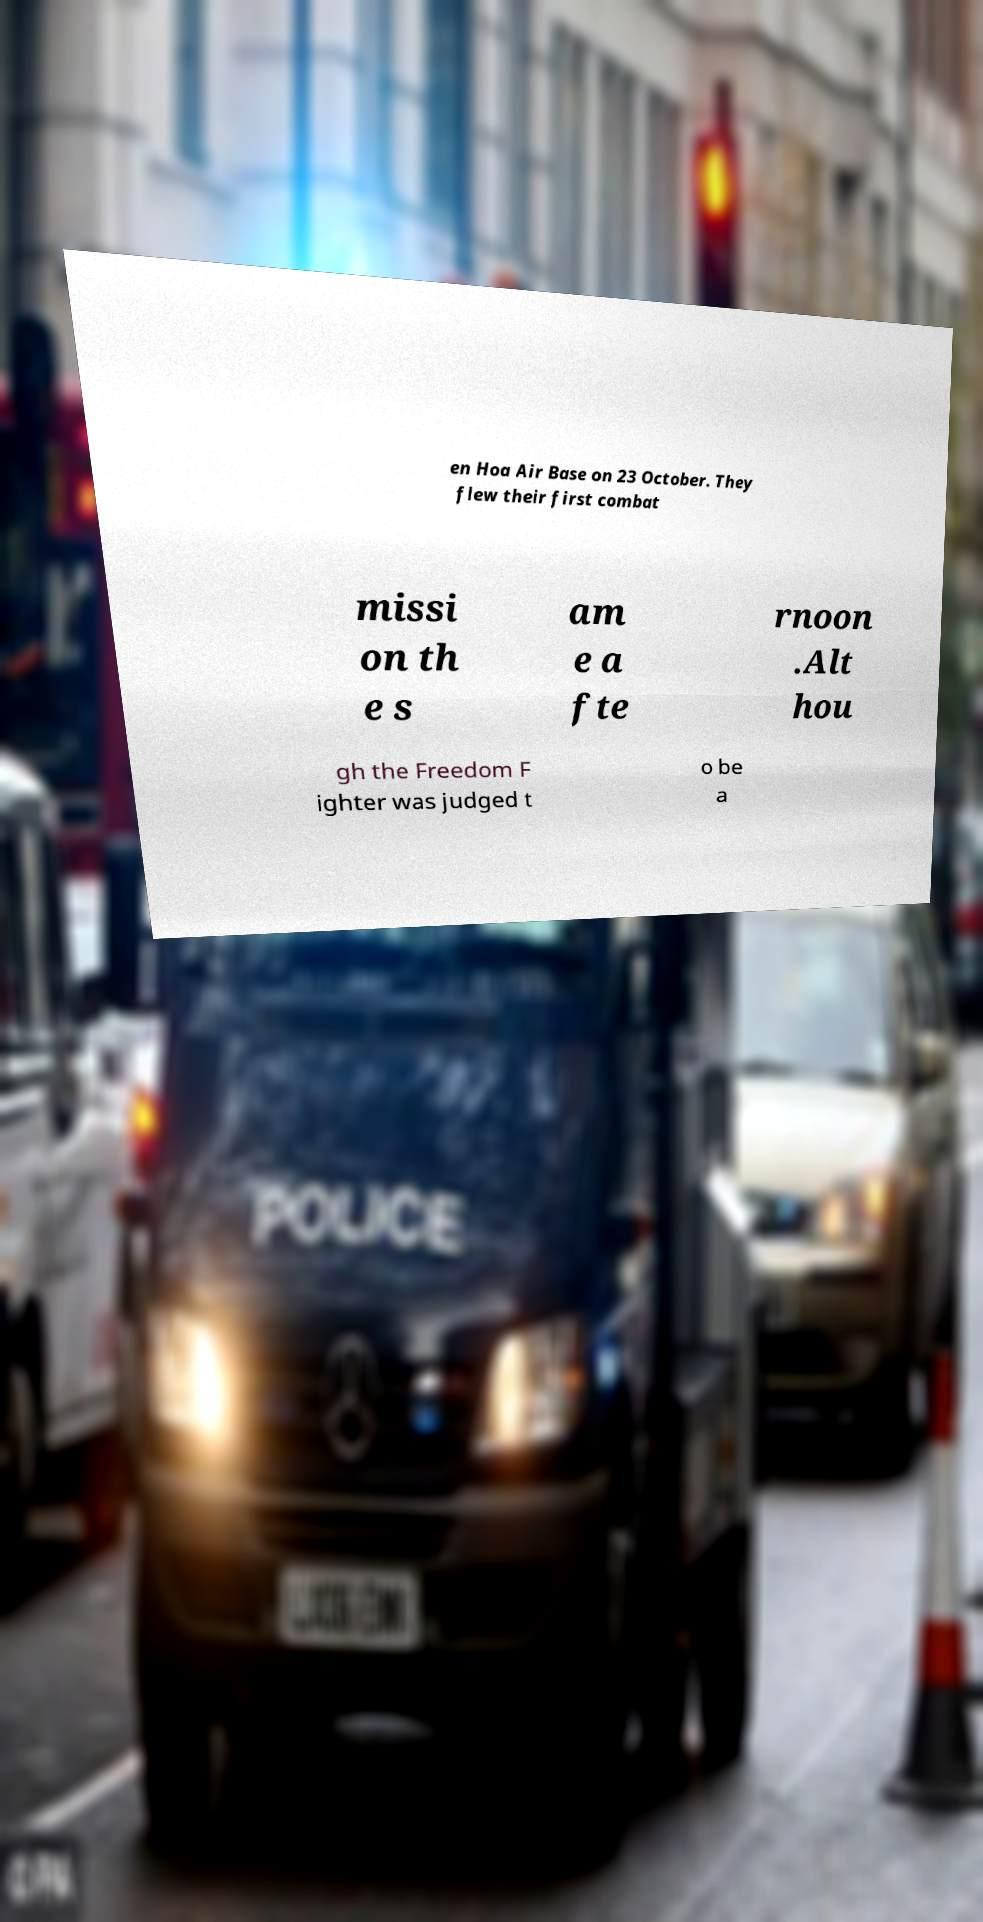What messages or text are displayed in this image? I need them in a readable, typed format. en Hoa Air Base on 23 October. They flew their first combat missi on th e s am e a fte rnoon .Alt hou gh the Freedom F ighter was judged t o be a 